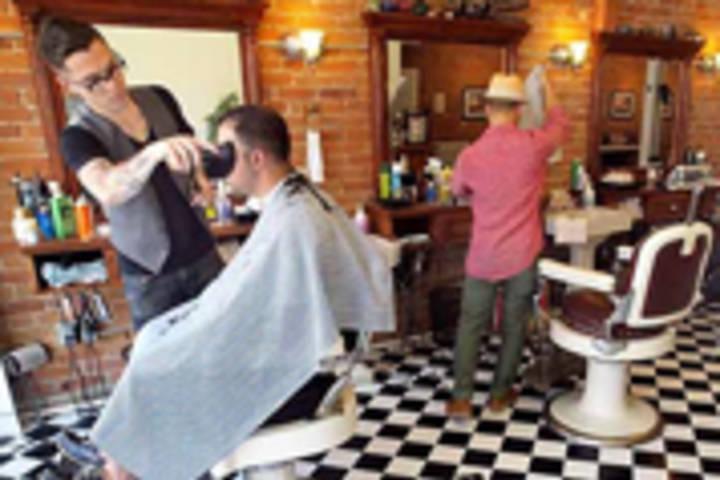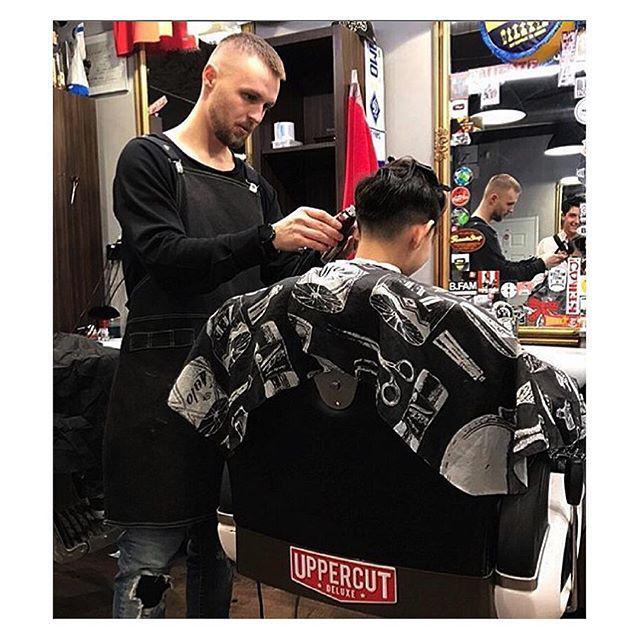The first image is the image on the left, the second image is the image on the right. For the images shown, is this caption "THere are exactly two people in the image on the left." true? Answer yes or no. No. 